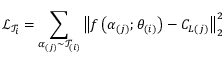<formula> <loc_0><loc_0><loc_500><loc_500>\mathcal { L } _ { \mathcal { T } _ { i } } = \sum _ { \alpha _ { ( j ) } \sim \mathcal { T } _ { ( i ) } } \left \| f \left ( \alpha _ { ( j ) } ; \theta _ { ( i ) } \right ) - C _ { L ( j ) } \right \| _ { 2 } ^ { 2 }</formula> 